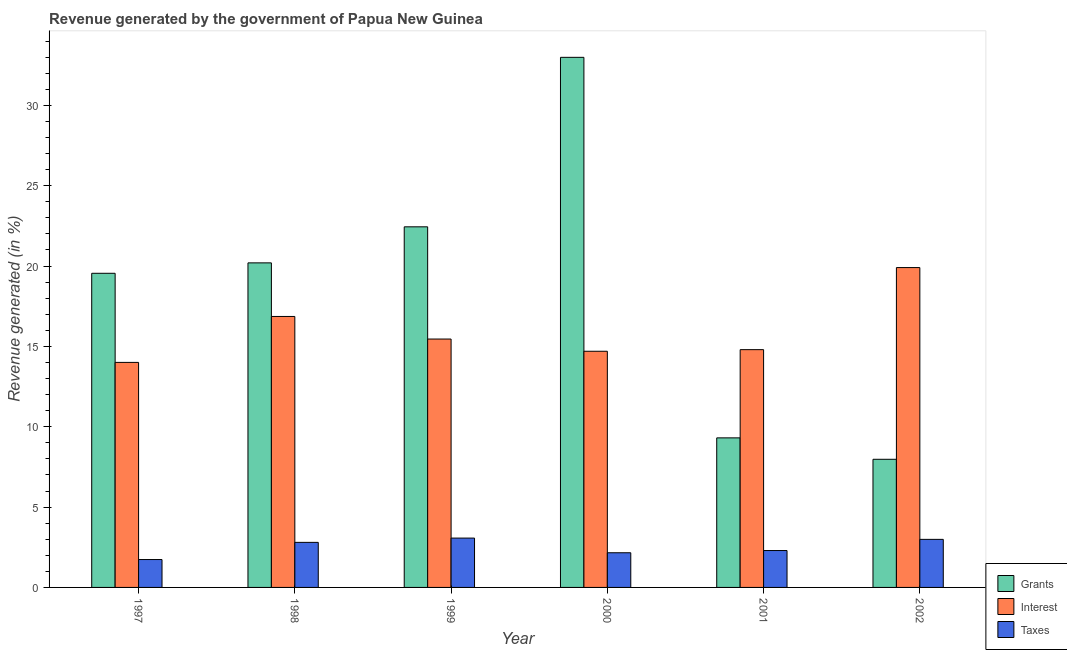How many different coloured bars are there?
Offer a very short reply. 3. Are the number of bars per tick equal to the number of legend labels?
Ensure brevity in your answer.  Yes. What is the label of the 1st group of bars from the left?
Your answer should be compact. 1997. What is the percentage of revenue generated by interest in 2000?
Your answer should be very brief. 14.7. Across all years, what is the maximum percentage of revenue generated by interest?
Ensure brevity in your answer.  19.9. Across all years, what is the minimum percentage of revenue generated by taxes?
Provide a succinct answer. 1.74. What is the total percentage of revenue generated by taxes in the graph?
Provide a succinct answer. 15.05. What is the difference between the percentage of revenue generated by interest in 1999 and that in 2002?
Keep it short and to the point. -4.45. What is the difference between the percentage of revenue generated by interest in 1999 and the percentage of revenue generated by grants in 1997?
Offer a very short reply. 1.45. What is the average percentage of revenue generated by taxes per year?
Your answer should be compact. 2.51. What is the ratio of the percentage of revenue generated by taxes in 1998 to that in 1999?
Provide a succinct answer. 0.91. Is the percentage of revenue generated by grants in 1997 less than that in 2002?
Offer a terse response. No. Is the difference between the percentage of revenue generated by taxes in 1997 and 2002 greater than the difference between the percentage of revenue generated by grants in 1997 and 2002?
Ensure brevity in your answer.  No. What is the difference between the highest and the second highest percentage of revenue generated by interest?
Provide a succinct answer. 3.04. What is the difference between the highest and the lowest percentage of revenue generated by taxes?
Offer a terse response. 1.33. Is the sum of the percentage of revenue generated by interest in 1998 and 2002 greater than the maximum percentage of revenue generated by grants across all years?
Offer a terse response. Yes. What does the 1st bar from the left in 2002 represents?
Provide a short and direct response. Grants. What does the 3rd bar from the right in 2002 represents?
Provide a succinct answer. Grants. Are all the bars in the graph horizontal?
Offer a terse response. No. Does the graph contain grids?
Ensure brevity in your answer.  No. How many legend labels are there?
Ensure brevity in your answer.  3. What is the title of the graph?
Offer a very short reply. Revenue generated by the government of Papua New Guinea. Does "Tertiary education" appear as one of the legend labels in the graph?
Offer a terse response. No. What is the label or title of the X-axis?
Your response must be concise. Year. What is the label or title of the Y-axis?
Make the answer very short. Revenue generated (in %). What is the Revenue generated (in %) in Grants in 1997?
Your answer should be very brief. 19.55. What is the Revenue generated (in %) of Interest in 1997?
Your answer should be very brief. 14. What is the Revenue generated (in %) of Taxes in 1997?
Offer a very short reply. 1.74. What is the Revenue generated (in %) in Grants in 1998?
Offer a terse response. 20.2. What is the Revenue generated (in %) of Interest in 1998?
Offer a terse response. 16.86. What is the Revenue generated (in %) in Taxes in 1998?
Offer a terse response. 2.8. What is the Revenue generated (in %) of Grants in 1999?
Your answer should be very brief. 22.44. What is the Revenue generated (in %) in Interest in 1999?
Your answer should be compact. 15.46. What is the Revenue generated (in %) in Taxes in 1999?
Give a very brief answer. 3.07. What is the Revenue generated (in %) in Grants in 2000?
Your answer should be very brief. 32.99. What is the Revenue generated (in %) in Interest in 2000?
Your answer should be very brief. 14.7. What is the Revenue generated (in %) of Taxes in 2000?
Offer a terse response. 2.16. What is the Revenue generated (in %) of Grants in 2001?
Offer a terse response. 9.31. What is the Revenue generated (in %) in Interest in 2001?
Give a very brief answer. 14.8. What is the Revenue generated (in %) in Taxes in 2001?
Your response must be concise. 2.3. What is the Revenue generated (in %) in Grants in 2002?
Give a very brief answer. 7.97. What is the Revenue generated (in %) in Interest in 2002?
Keep it short and to the point. 19.9. What is the Revenue generated (in %) in Taxes in 2002?
Keep it short and to the point. 2.99. Across all years, what is the maximum Revenue generated (in %) of Grants?
Your answer should be very brief. 32.99. Across all years, what is the maximum Revenue generated (in %) of Interest?
Your answer should be very brief. 19.9. Across all years, what is the maximum Revenue generated (in %) in Taxes?
Your answer should be very brief. 3.07. Across all years, what is the minimum Revenue generated (in %) of Grants?
Your response must be concise. 7.97. Across all years, what is the minimum Revenue generated (in %) in Interest?
Provide a succinct answer. 14. Across all years, what is the minimum Revenue generated (in %) in Taxes?
Give a very brief answer. 1.74. What is the total Revenue generated (in %) of Grants in the graph?
Keep it short and to the point. 112.46. What is the total Revenue generated (in %) in Interest in the graph?
Provide a short and direct response. 95.72. What is the total Revenue generated (in %) of Taxes in the graph?
Offer a very short reply. 15.05. What is the difference between the Revenue generated (in %) of Grants in 1997 and that in 1998?
Offer a very short reply. -0.65. What is the difference between the Revenue generated (in %) in Interest in 1997 and that in 1998?
Your response must be concise. -2.86. What is the difference between the Revenue generated (in %) in Taxes in 1997 and that in 1998?
Offer a terse response. -1.07. What is the difference between the Revenue generated (in %) in Grants in 1997 and that in 1999?
Offer a terse response. -2.89. What is the difference between the Revenue generated (in %) in Interest in 1997 and that in 1999?
Provide a succinct answer. -1.45. What is the difference between the Revenue generated (in %) of Taxes in 1997 and that in 1999?
Give a very brief answer. -1.33. What is the difference between the Revenue generated (in %) of Grants in 1997 and that in 2000?
Your answer should be very brief. -13.44. What is the difference between the Revenue generated (in %) of Interest in 1997 and that in 2000?
Provide a succinct answer. -0.69. What is the difference between the Revenue generated (in %) of Taxes in 1997 and that in 2000?
Offer a very short reply. -0.42. What is the difference between the Revenue generated (in %) in Grants in 1997 and that in 2001?
Offer a very short reply. 10.24. What is the difference between the Revenue generated (in %) of Interest in 1997 and that in 2001?
Ensure brevity in your answer.  -0.79. What is the difference between the Revenue generated (in %) in Taxes in 1997 and that in 2001?
Provide a short and direct response. -0.56. What is the difference between the Revenue generated (in %) in Grants in 1997 and that in 2002?
Make the answer very short. 11.58. What is the difference between the Revenue generated (in %) in Interest in 1997 and that in 2002?
Your answer should be compact. -5.9. What is the difference between the Revenue generated (in %) in Taxes in 1997 and that in 2002?
Provide a short and direct response. -1.26. What is the difference between the Revenue generated (in %) in Grants in 1998 and that in 1999?
Ensure brevity in your answer.  -2.24. What is the difference between the Revenue generated (in %) in Interest in 1998 and that in 1999?
Your answer should be very brief. 1.41. What is the difference between the Revenue generated (in %) of Taxes in 1998 and that in 1999?
Your answer should be very brief. -0.27. What is the difference between the Revenue generated (in %) in Grants in 1998 and that in 2000?
Offer a terse response. -12.79. What is the difference between the Revenue generated (in %) of Interest in 1998 and that in 2000?
Provide a short and direct response. 2.17. What is the difference between the Revenue generated (in %) of Taxes in 1998 and that in 2000?
Keep it short and to the point. 0.65. What is the difference between the Revenue generated (in %) of Grants in 1998 and that in 2001?
Provide a succinct answer. 10.89. What is the difference between the Revenue generated (in %) in Interest in 1998 and that in 2001?
Your answer should be compact. 2.07. What is the difference between the Revenue generated (in %) in Taxes in 1998 and that in 2001?
Provide a short and direct response. 0.51. What is the difference between the Revenue generated (in %) in Grants in 1998 and that in 2002?
Give a very brief answer. 12.22. What is the difference between the Revenue generated (in %) of Interest in 1998 and that in 2002?
Your answer should be very brief. -3.04. What is the difference between the Revenue generated (in %) of Taxes in 1998 and that in 2002?
Keep it short and to the point. -0.19. What is the difference between the Revenue generated (in %) in Grants in 1999 and that in 2000?
Give a very brief answer. -10.55. What is the difference between the Revenue generated (in %) in Interest in 1999 and that in 2000?
Ensure brevity in your answer.  0.76. What is the difference between the Revenue generated (in %) of Taxes in 1999 and that in 2000?
Provide a succinct answer. 0.91. What is the difference between the Revenue generated (in %) in Grants in 1999 and that in 2001?
Your answer should be very brief. 13.13. What is the difference between the Revenue generated (in %) in Interest in 1999 and that in 2001?
Your response must be concise. 0.66. What is the difference between the Revenue generated (in %) of Taxes in 1999 and that in 2001?
Keep it short and to the point. 0.77. What is the difference between the Revenue generated (in %) of Grants in 1999 and that in 2002?
Your answer should be compact. 14.47. What is the difference between the Revenue generated (in %) of Interest in 1999 and that in 2002?
Provide a succinct answer. -4.45. What is the difference between the Revenue generated (in %) in Taxes in 1999 and that in 2002?
Make the answer very short. 0.08. What is the difference between the Revenue generated (in %) in Grants in 2000 and that in 2001?
Your answer should be very brief. 23.68. What is the difference between the Revenue generated (in %) in Interest in 2000 and that in 2001?
Ensure brevity in your answer.  -0.1. What is the difference between the Revenue generated (in %) in Taxes in 2000 and that in 2001?
Give a very brief answer. -0.14. What is the difference between the Revenue generated (in %) in Grants in 2000 and that in 2002?
Ensure brevity in your answer.  25.02. What is the difference between the Revenue generated (in %) of Interest in 2000 and that in 2002?
Offer a very short reply. -5.21. What is the difference between the Revenue generated (in %) in Taxes in 2000 and that in 2002?
Your answer should be compact. -0.83. What is the difference between the Revenue generated (in %) of Grants in 2001 and that in 2002?
Provide a succinct answer. 1.33. What is the difference between the Revenue generated (in %) of Interest in 2001 and that in 2002?
Your answer should be very brief. -5.11. What is the difference between the Revenue generated (in %) of Taxes in 2001 and that in 2002?
Provide a short and direct response. -0.7. What is the difference between the Revenue generated (in %) of Grants in 1997 and the Revenue generated (in %) of Interest in 1998?
Offer a very short reply. 2.69. What is the difference between the Revenue generated (in %) of Grants in 1997 and the Revenue generated (in %) of Taxes in 1998?
Make the answer very short. 16.75. What is the difference between the Revenue generated (in %) of Interest in 1997 and the Revenue generated (in %) of Taxes in 1998?
Provide a short and direct response. 11.2. What is the difference between the Revenue generated (in %) of Grants in 1997 and the Revenue generated (in %) of Interest in 1999?
Offer a terse response. 4.09. What is the difference between the Revenue generated (in %) in Grants in 1997 and the Revenue generated (in %) in Taxes in 1999?
Provide a short and direct response. 16.48. What is the difference between the Revenue generated (in %) in Interest in 1997 and the Revenue generated (in %) in Taxes in 1999?
Give a very brief answer. 10.93. What is the difference between the Revenue generated (in %) in Grants in 1997 and the Revenue generated (in %) in Interest in 2000?
Your answer should be compact. 4.85. What is the difference between the Revenue generated (in %) in Grants in 1997 and the Revenue generated (in %) in Taxes in 2000?
Provide a short and direct response. 17.39. What is the difference between the Revenue generated (in %) of Interest in 1997 and the Revenue generated (in %) of Taxes in 2000?
Ensure brevity in your answer.  11.85. What is the difference between the Revenue generated (in %) of Grants in 1997 and the Revenue generated (in %) of Interest in 2001?
Give a very brief answer. 4.75. What is the difference between the Revenue generated (in %) of Grants in 1997 and the Revenue generated (in %) of Taxes in 2001?
Offer a terse response. 17.25. What is the difference between the Revenue generated (in %) in Interest in 1997 and the Revenue generated (in %) in Taxes in 2001?
Keep it short and to the point. 11.71. What is the difference between the Revenue generated (in %) in Grants in 1997 and the Revenue generated (in %) in Interest in 2002?
Your response must be concise. -0.36. What is the difference between the Revenue generated (in %) in Grants in 1997 and the Revenue generated (in %) in Taxes in 2002?
Keep it short and to the point. 16.56. What is the difference between the Revenue generated (in %) of Interest in 1997 and the Revenue generated (in %) of Taxes in 2002?
Ensure brevity in your answer.  11.01. What is the difference between the Revenue generated (in %) in Grants in 1998 and the Revenue generated (in %) in Interest in 1999?
Keep it short and to the point. 4.74. What is the difference between the Revenue generated (in %) of Grants in 1998 and the Revenue generated (in %) of Taxes in 1999?
Offer a terse response. 17.13. What is the difference between the Revenue generated (in %) of Interest in 1998 and the Revenue generated (in %) of Taxes in 1999?
Your answer should be very brief. 13.79. What is the difference between the Revenue generated (in %) of Grants in 1998 and the Revenue generated (in %) of Interest in 2000?
Offer a terse response. 5.5. What is the difference between the Revenue generated (in %) in Grants in 1998 and the Revenue generated (in %) in Taxes in 2000?
Make the answer very short. 18.04. What is the difference between the Revenue generated (in %) of Interest in 1998 and the Revenue generated (in %) of Taxes in 2000?
Make the answer very short. 14.71. What is the difference between the Revenue generated (in %) of Grants in 1998 and the Revenue generated (in %) of Interest in 2001?
Keep it short and to the point. 5.4. What is the difference between the Revenue generated (in %) of Grants in 1998 and the Revenue generated (in %) of Taxes in 2001?
Offer a very short reply. 17.9. What is the difference between the Revenue generated (in %) in Interest in 1998 and the Revenue generated (in %) in Taxes in 2001?
Keep it short and to the point. 14.57. What is the difference between the Revenue generated (in %) of Grants in 1998 and the Revenue generated (in %) of Interest in 2002?
Offer a very short reply. 0.29. What is the difference between the Revenue generated (in %) of Grants in 1998 and the Revenue generated (in %) of Taxes in 2002?
Your response must be concise. 17.21. What is the difference between the Revenue generated (in %) in Interest in 1998 and the Revenue generated (in %) in Taxes in 2002?
Provide a succinct answer. 13.87. What is the difference between the Revenue generated (in %) of Grants in 1999 and the Revenue generated (in %) of Interest in 2000?
Keep it short and to the point. 7.74. What is the difference between the Revenue generated (in %) of Grants in 1999 and the Revenue generated (in %) of Taxes in 2000?
Give a very brief answer. 20.28. What is the difference between the Revenue generated (in %) in Interest in 1999 and the Revenue generated (in %) in Taxes in 2000?
Make the answer very short. 13.3. What is the difference between the Revenue generated (in %) of Grants in 1999 and the Revenue generated (in %) of Interest in 2001?
Your answer should be compact. 7.64. What is the difference between the Revenue generated (in %) in Grants in 1999 and the Revenue generated (in %) in Taxes in 2001?
Offer a terse response. 20.14. What is the difference between the Revenue generated (in %) in Interest in 1999 and the Revenue generated (in %) in Taxes in 2001?
Provide a succinct answer. 13.16. What is the difference between the Revenue generated (in %) in Grants in 1999 and the Revenue generated (in %) in Interest in 2002?
Make the answer very short. 2.54. What is the difference between the Revenue generated (in %) in Grants in 1999 and the Revenue generated (in %) in Taxes in 2002?
Keep it short and to the point. 19.45. What is the difference between the Revenue generated (in %) in Interest in 1999 and the Revenue generated (in %) in Taxes in 2002?
Your answer should be compact. 12.47. What is the difference between the Revenue generated (in %) of Grants in 2000 and the Revenue generated (in %) of Interest in 2001?
Your answer should be very brief. 18.19. What is the difference between the Revenue generated (in %) of Grants in 2000 and the Revenue generated (in %) of Taxes in 2001?
Your response must be concise. 30.69. What is the difference between the Revenue generated (in %) of Interest in 2000 and the Revenue generated (in %) of Taxes in 2001?
Keep it short and to the point. 12.4. What is the difference between the Revenue generated (in %) in Grants in 2000 and the Revenue generated (in %) in Interest in 2002?
Ensure brevity in your answer.  13.08. What is the difference between the Revenue generated (in %) in Grants in 2000 and the Revenue generated (in %) in Taxes in 2002?
Your response must be concise. 30. What is the difference between the Revenue generated (in %) of Interest in 2000 and the Revenue generated (in %) of Taxes in 2002?
Offer a very short reply. 11.71. What is the difference between the Revenue generated (in %) in Grants in 2001 and the Revenue generated (in %) in Interest in 2002?
Make the answer very short. -10.6. What is the difference between the Revenue generated (in %) in Grants in 2001 and the Revenue generated (in %) in Taxes in 2002?
Provide a short and direct response. 6.32. What is the difference between the Revenue generated (in %) in Interest in 2001 and the Revenue generated (in %) in Taxes in 2002?
Make the answer very short. 11.81. What is the average Revenue generated (in %) of Grants per year?
Your answer should be very brief. 18.74. What is the average Revenue generated (in %) of Interest per year?
Provide a succinct answer. 15.95. What is the average Revenue generated (in %) in Taxes per year?
Offer a very short reply. 2.51. In the year 1997, what is the difference between the Revenue generated (in %) of Grants and Revenue generated (in %) of Interest?
Make the answer very short. 5.55. In the year 1997, what is the difference between the Revenue generated (in %) of Grants and Revenue generated (in %) of Taxes?
Your response must be concise. 17.81. In the year 1997, what is the difference between the Revenue generated (in %) in Interest and Revenue generated (in %) in Taxes?
Keep it short and to the point. 12.27. In the year 1998, what is the difference between the Revenue generated (in %) of Grants and Revenue generated (in %) of Interest?
Give a very brief answer. 3.33. In the year 1998, what is the difference between the Revenue generated (in %) in Grants and Revenue generated (in %) in Taxes?
Your answer should be compact. 17.39. In the year 1998, what is the difference between the Revenue generated (in %) in Interest and Revenue generated (in %) in Taxes?
Your answer should be very brief. 14.06. In the year 1999, what is the difference between the Revenue generated (in %) of Grants and Revenue generated (in %) of Interest?
Your response must be concise. 6.98. In the year 1999, what is the difference between the Revenue generated (in %) in Grants and Revenue generated (in %) in Taxes?
Provide a succinct answer. 19.37. In the year 1999, what is the difference between the Revenue generated (in %) of Interest and Revenue generated (in %) of Taxes?
Offer a terse response. 12.39. In the year 2000, what is the difference between the Revenue generated (in %) in Grants and Revenue generated (in %) in Interest?
Make the answer very short. 18.29. In the year 2000, what is the difference between the Revenue generated (in %) of Grants and Revenue generated (in %) of Taxes?
Provide a succinct answer. 30.83. In the year 2000, what is the difference between the Revenue generated (in %) of Interest and Revenue generated (in %) of Taxes?
Your answer should be very brief. 12.54. In the year 2001, what is the difference between the Revenue generated (in %) of Grants and Revenue generated (in %) of Interest?
Provide a short and direct response. -5.49. In the year 2001, what is the difference between the Revenue generated (in %) in Grants and Revenue generated (in %) in Taxes?
Make the answer very short. 7.01. In the year 2001, what is the difference between the Revenue generated (in %) in Interest and Revenue generated (in %) in Taxes?
Keep it short and to the point. 12.5. In the year 2002, what is the difference between the Revenue generated (in %) in Grants and Revenue generated (in %) in Interest?
Keep it short and to the point. -11.93. In the year 2002, what is the difference between the Revenue generated (in %) of Grants and Revenue generated (in %) of Taxes?
Offer a terse response. 4.98. In the year 2002, what is the difference between the Revenue generated (in %) in Interest and Revenue generated (in %) in Taxes?
Make the answer very short. 16.91. What is the ratio of the Revenue generated (in %) in Grants in 1997 to that in 1998?
Your answer should be very brief. 0.97. What is the ratio of the Revenue generated (in %) in Interest in 1997 to that in 1998?
Your answer should be very brief. 0.83. What is the ratio of the Revenue generated (in %) of Taxes in 1997 to that in 1998?
Give a very brief answer. 0.62. What is the ratio of the Revenue generated (in %) in Grants in 1997 to that in 1999?
Your answer should be very brief. 0.87. What is the ratio of the Revenue generated (in %) in Interest in 1997 to that in 1999?
Give a very brief answer. 0.91. What is the ratio of the Revenue generated (in %) in Taxes in 1997 to that in 1999?
Make the answer very short. 0.57. What is the ratio of the Revenue generated (in %) of Grants in 1997 to that in 2000?
Provide a succinct answer. 0.59. What is the ratio of the Revenue generated (in %) of Interest in 1997 to that in 2000?
Keep it short and to the point. 0.95. What is the ratio of the Revenue generated (in %) of Taxes in 1997 to that in 2000?
Offer a terse response. 0.8. What is the ratio of the Revenue generated (in %) in Grants in 1997 to that in 2001?
Provide a short and direct response. 2.1. What is the ratio of the Revenue generated (in %) in Interest in 1997 to that in 2001?
Provide a short and direct response. 0.95. What is the ratio of the Revenue generated (in %) of Taxes in 1997 to that in 2001?
Give a very brief answer. 0.76. What is the ratio of the Revenue generated (in %) of Grants in 1997 to that in 2002?
Give a very brief answer. 2.45. What is the ratio of the Revenue generated (in %) of Interest in 1997 to that in 2002?
Offer a terse response. 0.7. What is the ratio of the Revenue generated (in %) of Taxes in 1997 to that in 2002?
Keep it short and to the point. 0.58. What is the ratio of the Revenue generated (in %) in Grants in 1998 to that in 1999?
Offer a very short reply. 0.9. What is the ratio of the Revenue generated (in %) in Taxes in 1998 to that in 1999?
Your response must be concise. 0.91. What is the ratio of the Revenue generated (in %) of Grants in 1998 to that in 2000?
Ensure brevity in your answer.  0.61. What is the ratio of the Revenue generated (in %) in Interest in 1998 to that in 2000?
Make the answer very short. 1.15. What is the ratio of the Revenue generated (in %) in Taxes in 1998 to that in 2000?
Provide a succinct answer. 1.3. What is the ratio of the Revenue generated (in %) in Grants in 1998 to that in 2001?
Your response must be concise. 2.17. What is the ratio of the Revenue generated (in %) in Interest in 1998 to that in 2001?
Your response must be concise. 1.14. What is the ratio of the Revenue generated (in %) in Taxes in 1998 to that in 2001?
Your answer should be very brief. 1.22. What is the ratio of the Revenue generated (in %) of Grants in 1998 to that in 2002?
Keep it short and to the point. 2.53. What is the ratio of the Revenue generated (in %) in Interest in 1998 to that in 2002?
Your response must be concise. 0.85. What is the ratio of the Revenue generated (in %) of Taxes in 1998 to that in 2002?
Offer a very short reply. 0.94. What is the ratio of the Revenue generated (in %) in Grants in 1999 to that in 2000?
Keep it short and to the point. 0.68. What is the ratio of the Revenue generated (in %) of Interest in 1999 to that in 2000?
Offer a very short reply. 1.05. What is the ratio of the Revenue generated (in %) of Taxes in 1999 to that in 2000?
Your response must be concise. 1.42. What is the ratio of the Revenue generated (in %) of Grants in 1999 to that in 2001?
Keep it short and to the point. 2.41. What is the ratio of the Revenue generated (in %) of Interest in 1999 to that in 2001?
Keep it short and to the point. 1.04. What is the ratio of the Revenue generated (in %) of Taxes in 1999 to that in 2001?
Your response must be concise. 1.34. What is the ratio of the Revenue generated (in %) of Grants in 1999 to that in 2002?
Make the answer very short. 2.81. What is the ratio of the Revenue generated (in %) of Interest in 1999 to that in 2002?
Give a very brief answer. 0.78. What is the ratio of the Revenue generated (in %) of Taxes in 1999 to that in 2002?
Offer a terse response. 1.03. What is the ratio of the Revenue generated (in %) of Grants in 2000 to that in 2001?
Your answer should be very brief. 3.54. What is the ratio of the Revenue generated (in %) in Interest in 2000 to that in 2001?
Keep it short and to the point. 0.99. What is the ratio of the Revenue generated (in %) of Taxes in 2000 to that in 2001?
Provide a succinct answer. 0.94. What is the ratio of the Revenue generated (in %) in Grants in 2000 to that in 2002?
Your answer should be very brief. 4.14. What is the ratio of the Revenue generated (in %) in Interest in 2000 to that in 2002?
Your answer should be very brief. 0.74. What is the ratio of the Revenue generated (in %) of Taxes in 2000 to that in 2002?
Offer a terse response. 0.72. What is the ratio of the Revenue generated (in %) of Grants in 2001 to that in 2002?
Your response must be concise. 1.17. What is the ratio of the Revenue generated (in %) of Interest in 2001 to that in 2002?
Your response must be concise. 0.74. What is the ratio of the Revenue generated (in %) in Taxes in 2001 to that in 2002?
Make the answer very short. 0.77. What is the difference between the highest and the second highest Revenue generated (in %) of Grants?
Your answer should be very brief. 10.55. What is the difference between the highest and the second highest Revenue generated (in %) in Interest?
Your answer should be compact. 3.04. What is the difference between the highest and the second highest Revenue generated (in %) in Taxes?
Provide a succinct answer. 0.08. What is the difference between the highest and the lowest Revenue generated (in %) in Grants?
Your answer should be very brief. 25.02. What is the difference between the highest and the lowest Revenue generated (in %) of Interest?
Provide a short and direct response. 5.9. What is the difference between the highest and the lowest Revenue generated (in %) in Taxes?
Make the answer very short. 1.33. 